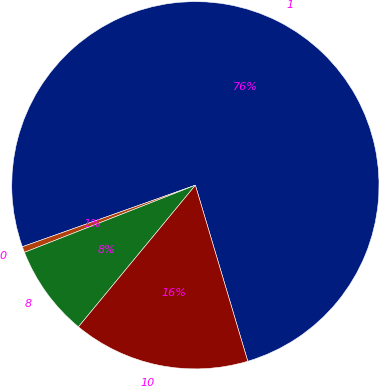<chart> <loc_0><loc_0><loc_500><loc_500><pie_chart><fcel>1<fcel>0<fcel>8<fcel>10<nl><fcel>75.83%<fcel>0.52%<fcel>8.06%<fcel>15.59%<nl></chart> 